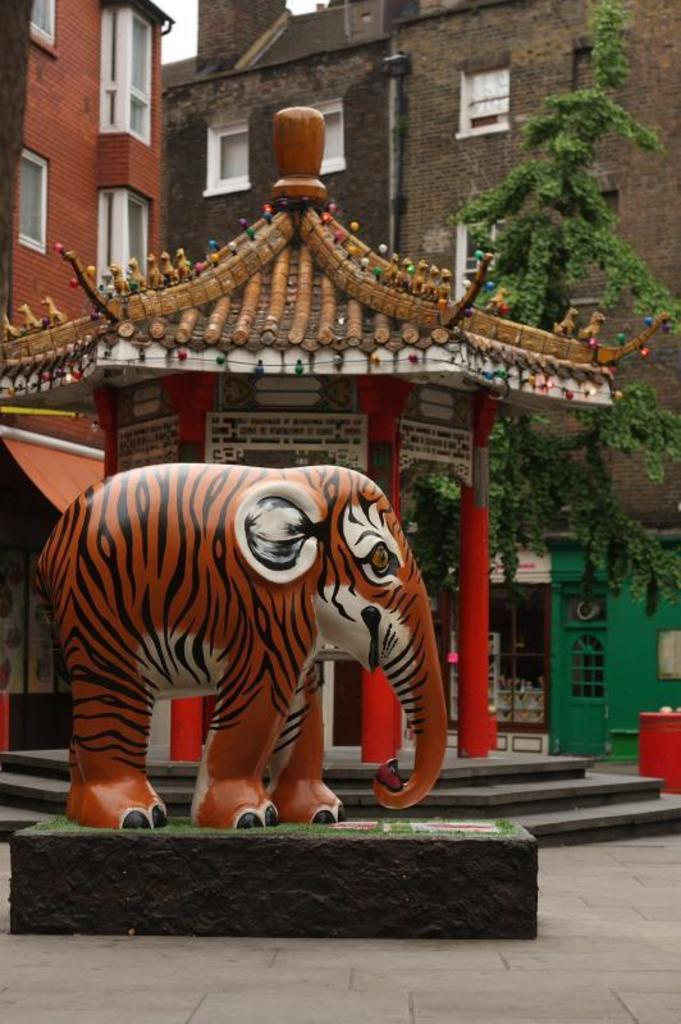What is the main subject of the image? There is a statue of an elephant on the road. What can be seen in the background of the image? There are buildings with windows in the image. What type of vegetation is present in the image? There is a tree in the image. What type of sponge is being used to clean the windows of the buildings in the image? There is no sponge visible in the image, and no indication that the windows are being cleaned. 